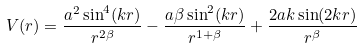<formula> <loc_0><loc_0><loc_500><loc_500>V ( r ) = \frac { a ^ { 2 } \sin ^ { 4 } ( k r ) } { r ^ { 2 \beta } } - \frac { a \beta \sin ^ { 2 } ( k r ) } { r ^ { 1 + \beta } } + \frac { 2 a k \sin ( 2 k r ) } { r ^ { \beta } }</formula> 